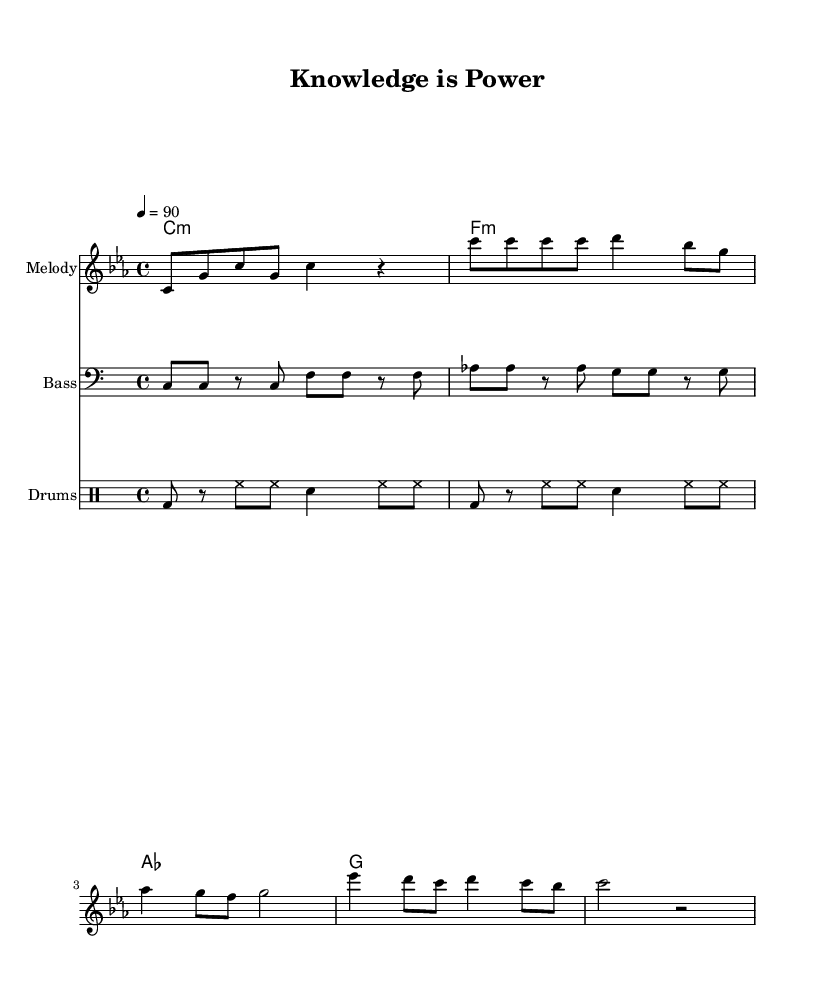What is the key signature of this music? The key signature is C minor, which consists of three flats. You can identify the key signature by looking at the beginning of the staff where the flats are located.
Answer: C minor What is the time signature of this music? The time signature is 4/4, meaning there are four beats in each measure and a quarter note receives one beat. It can be found at the beginning of the piece, right after the key signature.
Answer: 4/4 What is the tempo marking for this piece? The tempo marking indicates a speed of 90 beats per minute, which can be found written just above the staff, under the global settings. This tells the performer how fast to play the piece.
Answer: 90 How many measures are in the chorus section? The chorus contains 2 measures, as identified by counting the bars in the section of the music labeled as "Chorus." Each vertical line represents a measure.
Answer: 2 What chord follows the A flat major chord in the harmony? After the A flat major chord (as), the next chord in the harmony is G major (g). This can be seen by examining the sequence of chords written under the melody staff.
Answer: G What instrument is indicated for the melody part? The instrument indicated for the melody part is "Melody," as stated at the beginning of the melody staff, which helps identify what instrument should play that line.
Answer: Melody What rhythmic pattern is primarily used for the drums? The primary rhythmic pattern for the drums consists of a series of bass and hi-hat notes, organized by groups as seen in the drum staff, contributing to the hip-hop feel of the piece.
Answer: Bass and hi-hat 